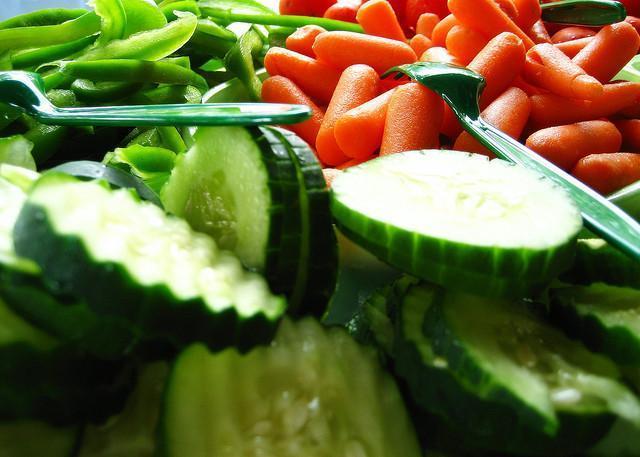How many forks are there?
Give a very brief answer. 2. How many carrots are there?
Give a very brief answer. 12. 